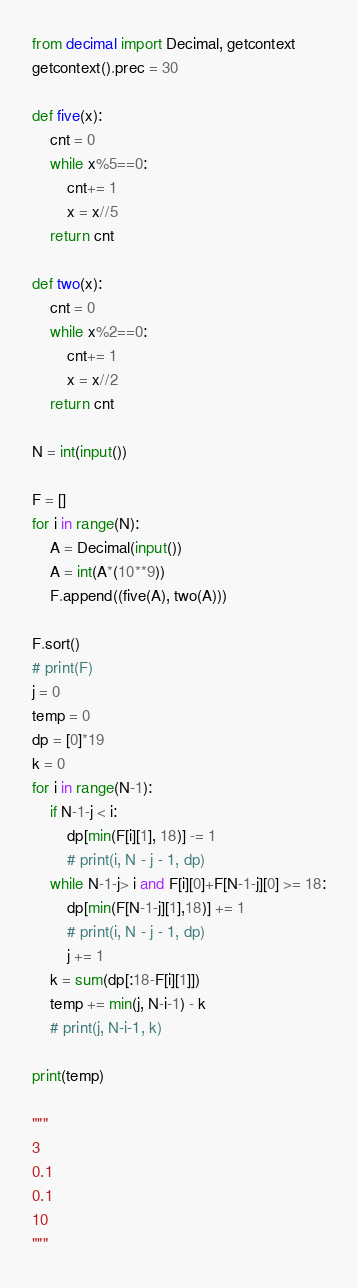Convert code to text. <code><loc_0><loc_0><loc_500><loc_500><_Python_>from decimal import Decimal, getcontext
getcontext().prec = 30

def five(x):
    cnt = 0
    while x%5==0:
        cnt+= 1
        x = x//5
    return cnt

def two(x):
    cnt = 0
    while x%2==0:
        cnt+= 1
        x = x//2
    return cnt

N = int(input())

F = []
for i in range(N):
    A = Decimal(input())
    A = int(A*(10**9))
    F.append((five(A), two(A)))

F.sort()
# print(F)
j = 0
temp = 0
dp = [0]*19
k = 0
for i in range(N-1):
    if N-1-j < i:
        dp[min(F[i][1], 18)] -= 1
        # print(i, N - j - 1, dp)
    while N-1-j> i and F[i][0]+F[N-1-j][0] >= 18:
        dp[min(F[N-1-j][1],18)] += 1
        # print(i, N - j - 1, dp)
        j += 1
    k = sum(dp[:18-F[i][1]])
    temp += min(j, N-i-1) - k
    # print(j, N-i-1, k)

print(temp)

"""
3
0.1
0.1
10
"""</code> 